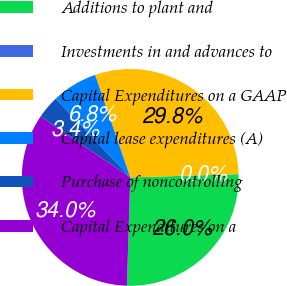Convert chart. <chart><loc_0><loc_0><loc_500><loc_500><pie_chart><fcel>Additions to plant and<fcel>Investments in and advances to<fcel>Capital Expenditures on a GAAP<fcel>Capital lease expenditures (A)<fcel>Purchase of noncontrolling<fcel>Capital Expenditures on a<nl><fcel>25.96%<fcel>0.02%<fcel>29.77%<fcel>6.82%<fcel>3.42%<fcel>34.01%<nl></chart> 